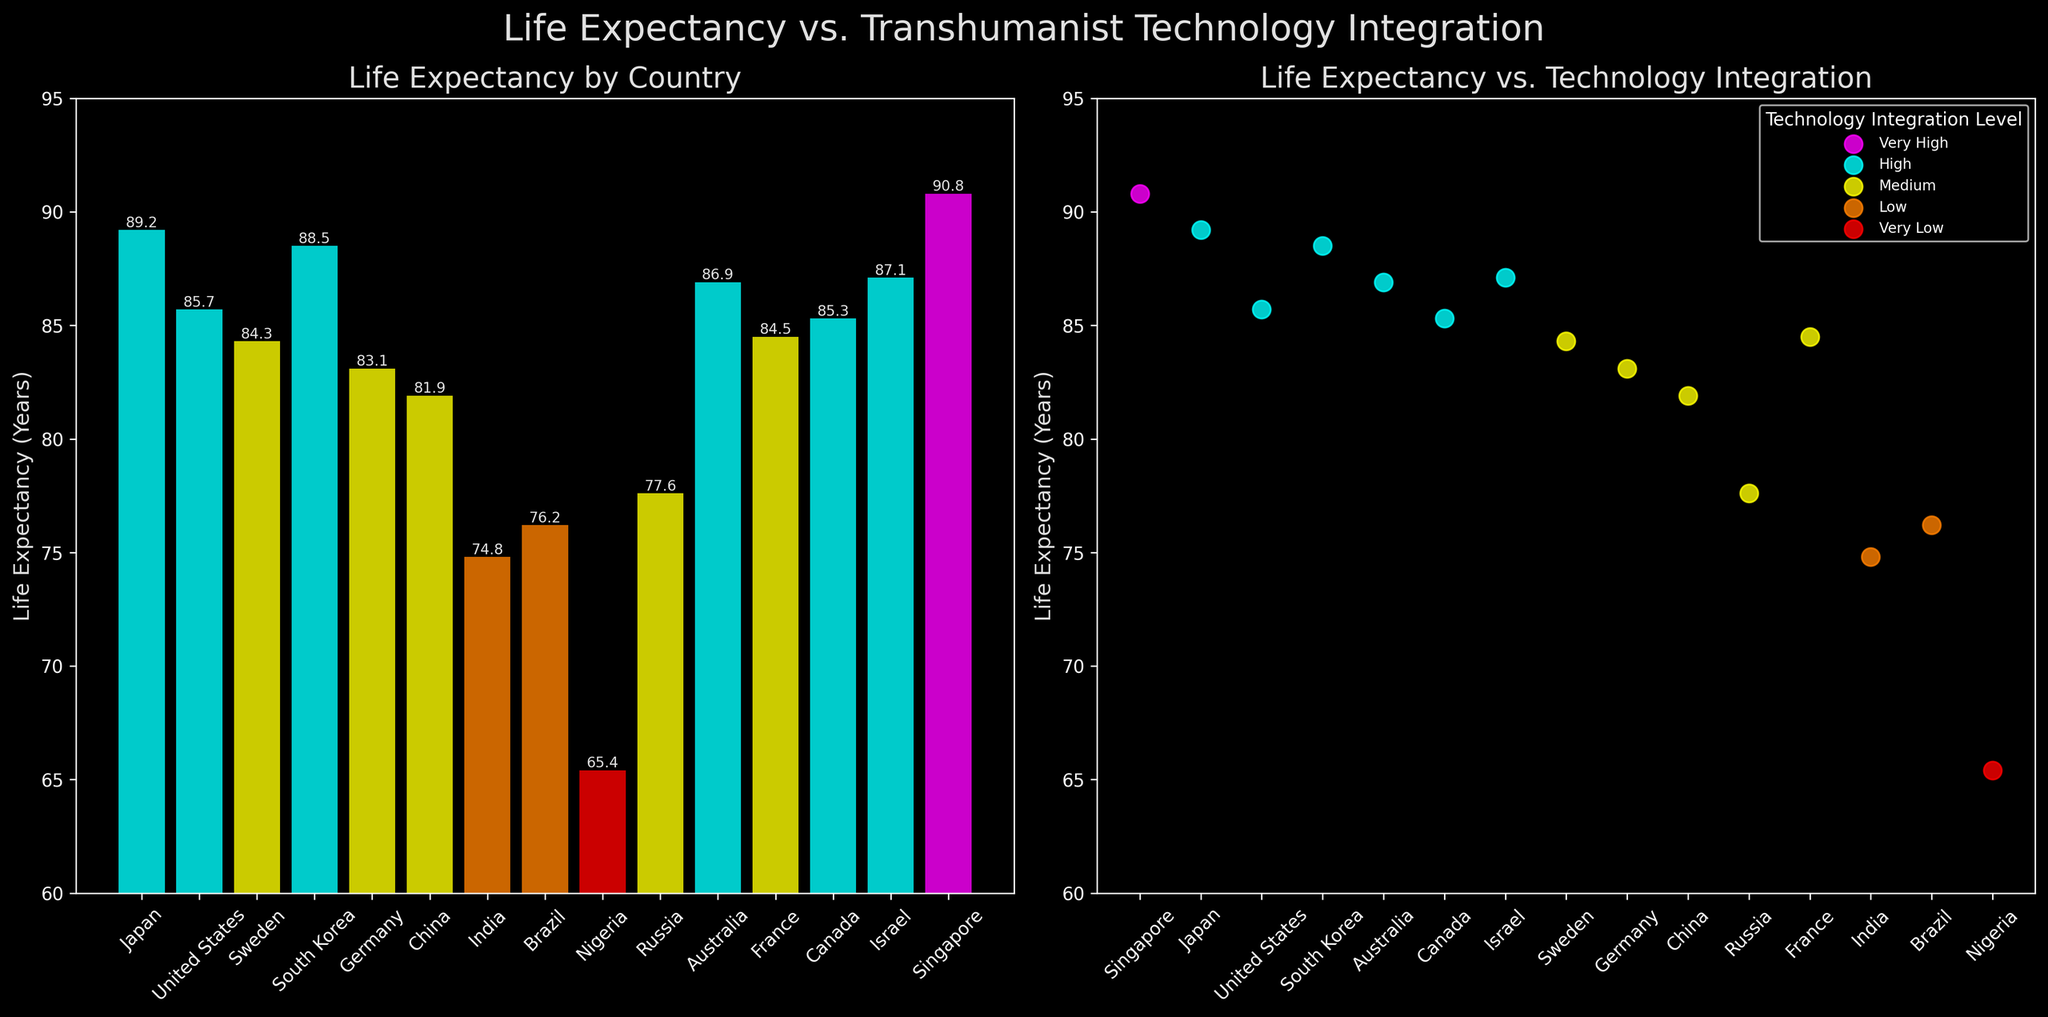What's the title of the figure? The title is located at the top center of the figure in a larger font size. It reads "Life Expectancy vs. Transhumanist Technology Integration".
Answer: Life Expectancy vs. Transhumanist Technology Integration What is the technology integration level for Japan? We can match the country "Japan" from the x-axis of the bar plot or the labels in the scatter plot to its corresponding color. Since Japan is colored in cyan, we can find that it belongs to the "High" technology integration level category according to the color legend.
Answer: High What is the life expectancy of Singapore? In the bar plot, locate the bar labeled Singapore and read the corresponding height or the value label on top of the bar. The value is 90.8 years.
Answer: 90.8 years How many countries fall under the "Medium" technology integration category? From the color legend, "Medium" is represented in yellow. By counting the yellow-colored bars in the bar plot or yellow data points in the scatter plot, we find there are five countries: Sweden, Germany, China, Russia, and France.
Answer: 5 Which country has the lowest life expectancy, and what is its value? In the bar plot, identify the shortest bar and its label, which corresponds to Nigeria. The life expectancy value is visible on top of the bar and in the scatter plot, listed as 65.4 years.
Answer: Nigeria, 65.4 years Compare the life expectancy of countries with "Very High" and "Very Low" technology integration levels. "Very High" technology integration is represented by magenta, and "Very Low" by red. In the plots, we see only one country in each category: Singapore with 90.8 years and Nigeria with 65.4 years. Thus, Singapore has a substantially higher life expectancy compared to Nigeria.
Answer: Singapore: 90.8 years, Nigeria: 65.4 years Which country has a higher life expectancy, Canada or the United States? Locate the bars or scatter points for both Canada and the United States. Canada’s life expectancy is labeled 85.3 years, while the United States is 85.7 years. Comparing these values, the United States has a slightly higher life expectancy.
Answer: United States Is there a visible trend between technology integration level and life expectancy? By observing the scatter plot, countries with higher technology integration levels (Very High, High) generally have a trend of higher life expectancies compared to those with lower levels (Low, Very Low).
Answer: Yes How does South Korea's life expectancy compare to the overall trend of countries with "High" technology integration? For the "High" integration category, South Korea has a life expectancy of 88.5 years. Comparing it to other "High" integration countries like Japan (89.2), the US (85.7), Australia (86.9), and Canada (85.3), South Korea's value fits within the upper range, reflecting the higher trend for countries with high technology integration.
Answer: Above average for high integration What is the difference in life expectancy between Germany and India? From the bar plot, Germany’s life expectancy is 83.1 years and India’s is 74.8 years. Subtracting these values, the difference is 83.1 - 74.8 = 8.3 years.
Answer: 8.3 years 